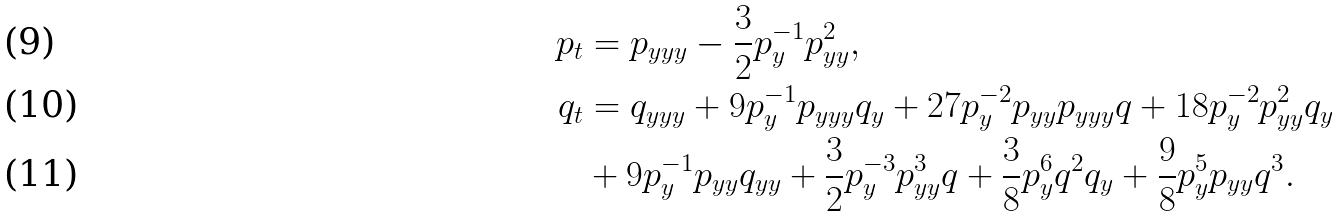Convert formula to latex. <formula><loc_0><loc_0><loc_500><loc_500>p _ { t } & = p _ { y y y } - \frac { 3 } { 2 } p _ { y } ^ { - 1 } p _ { y y } ^ { 2 } , \\ q _ { t } & = q _ { y y y } + 9 p _ { y } ^ { - 1 } p _ { y y y } q _ { y } + 2 7 p _ { y } ^ { - 2 } p _ { y y } p _ { y y y } q + 1 8 p _ { y } ^ { - 2 } p _ { y y } ^ { 2 } q _ { y } \\ & + 9 p _ { y } ^ { - 1 } p _ { y y } q _ { y y } + \frac { 3 } { 2 } p _ { y } ^ { - 3 } p _ { y y } ^ { 3 } q + \frac { 3 } { 8 } p _ { y } ^ { 6 } q ^ { 2 } q _ { y } + \frac { 9 } { 8 } p _ { y } ^ { 5 } p _ { y y } q ^ { 3 } .</formula> 